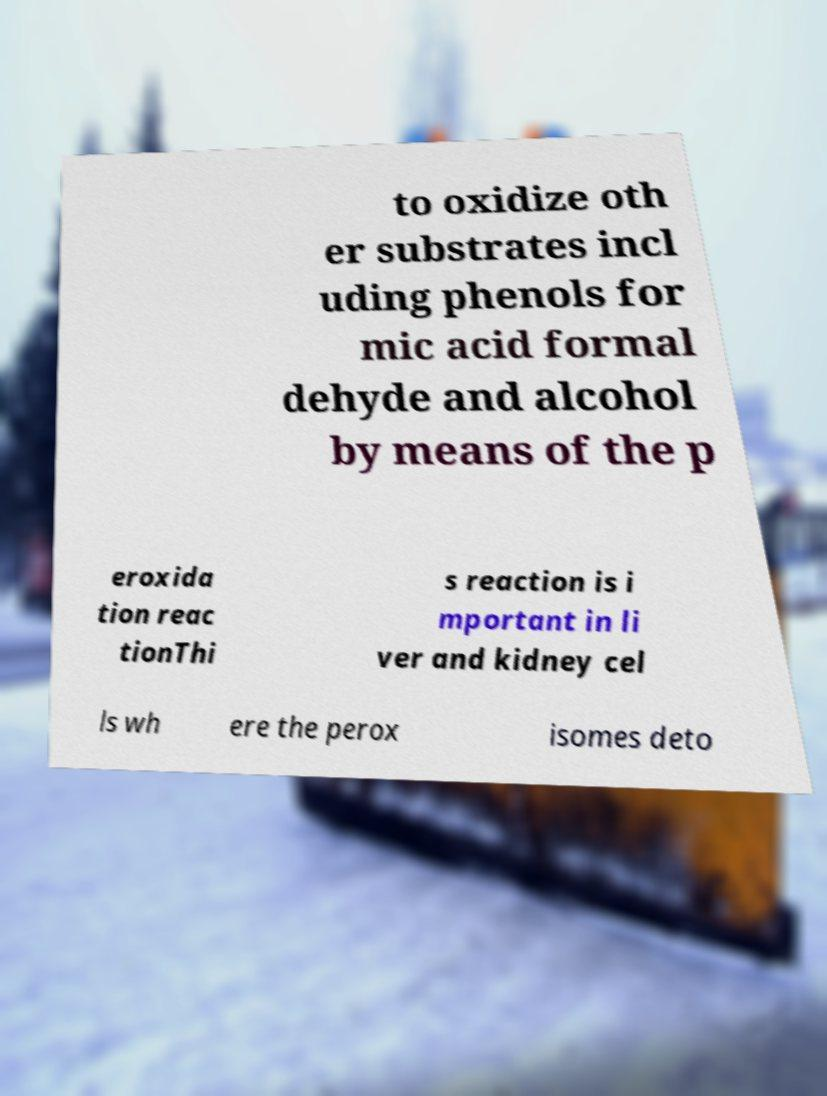Could you assist in decoding the text presented in this image and type it out clearly? to oxidize oth er substrates incl uding phenols for mic acid formal dehyde and alcohol by means of the p eroxida tion reac tionThi s reaction is i mportant in li ver and kidney cel ls wh ere the perox isomes deto 